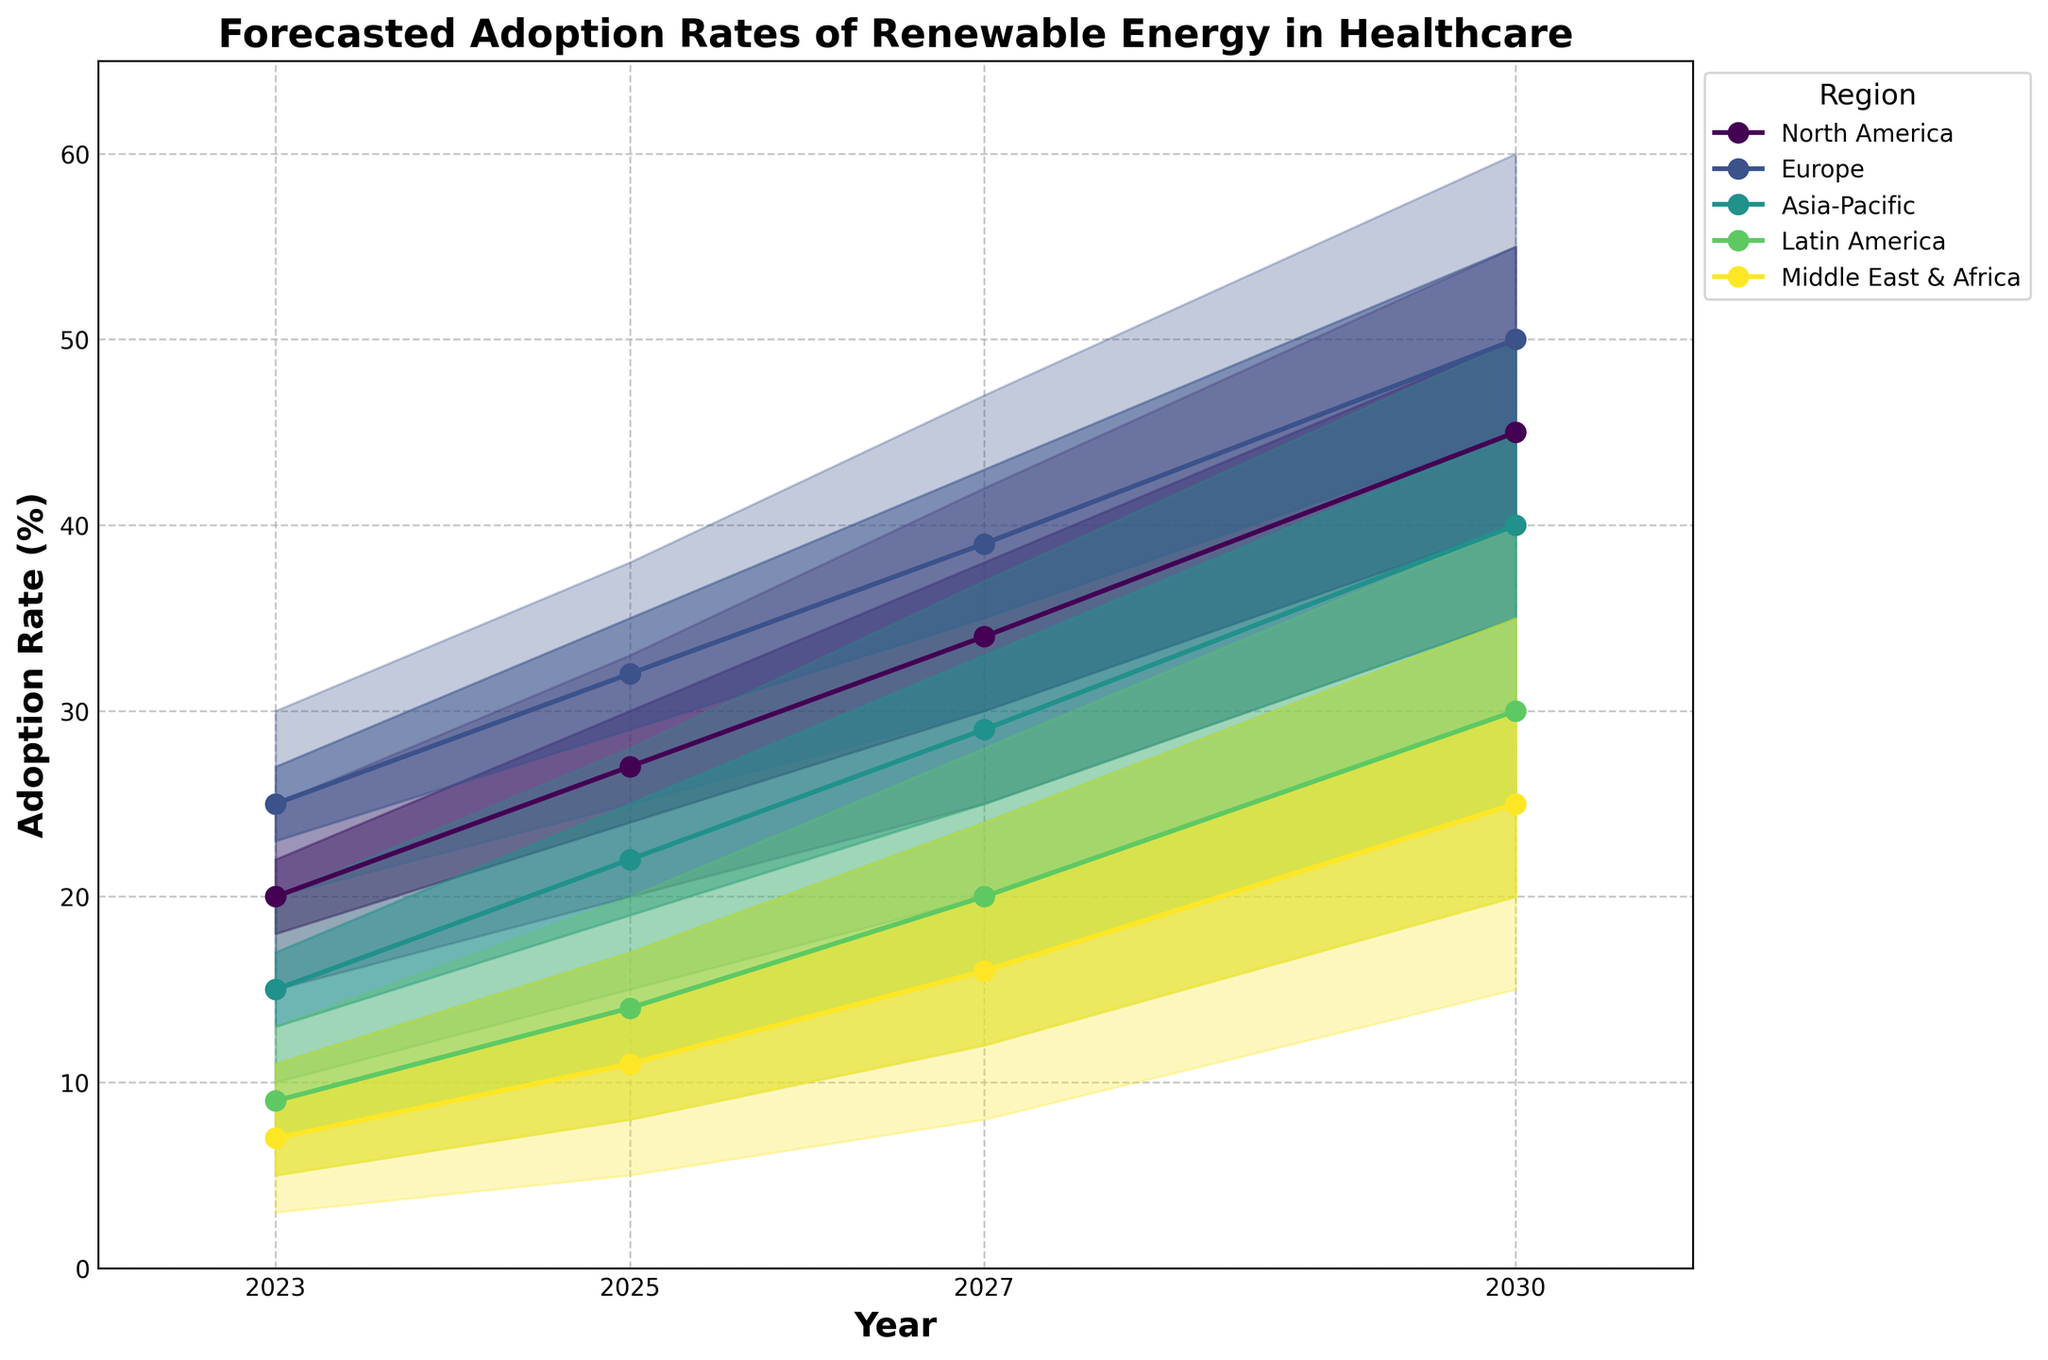What's the title of the chart? The title is usually displayed at the top of a chart. In this case, the title can be found at the top center, indicating the main topic of the chart.
Answer: Forecasted Adoption Rates of Renewable Energy in Healthcare What are the regions covered in the chart? The regions are typically indicated in the legend, which can be found on the figure. They describe the different areas for which data is presented.
Answer: North America, Europe, Asia-Pacific, Latin America, Middle East & Africa By 2027, what is the forecasted middle adoption rate of renewable energy in the Asia-Pacific region? The forecasted middle adoption rate is indicated by the central line in the fan charts for the given year and region. In 2027, for Asia-Pacific, this value is located at the point where the year 2027 intersects with the middle line.
Answer: 29% Which region is expected to have the highest adoption rate of renewable energy by 2030? To determine this, look at the highest forecasted values in 2030 for each region. The topmost line (high) in the fan chart represents this extreme.
Answer: Europe How does the forecasted adoption rate for Latin America in 2025 compare to the Middle East & Africa in 2027? Look at the forecasted middle adoption rates for each region. Latin America's mid-value in 2025 is 14%, and Middle East & Africa's mid-value in 2027 is 16%. Compare these two values.
Answer: The adoption rate in the Middle East & Africa in 2027 is higher What is the difference between the high and low forecasts for Europe in 2025? Find the high and low forecast values for Europe in 2025. The difference is calculated by subtracting the low value from the high value: 38 - 25.
Answer: 13% What trend can be observed for North America's median adoption rate from 2023 to 2030? Observe the median line for North America over the given years to identify the pattern. The median line for North America rises from 2023 (20%) to 2030 (45%).
Answer: Increasing trend For which region is the range (High to Low) of adoption rates largest in 2030? Look at the difference between High and Low values for each region in 2030. The region with the largest difference is obtained by comparing each range. Europe and North America both have the largest range which is 20%.
Answer: Europe and North America In 2025, which region is expected to have a higher adoption rate: Asia-Pacific or Latin America? Compare the middle adoption rates of Asia-Pacific and Latin America in 2025. Asia-Pacific has a mid-value of 22%, while Latin America has a mid-value of 14%.
Answer: Asia-Pacific By 2030, which region has the smallest forecasted range of adoption rates? To find this, compute the difference between the high and low forecasted values for each region in 2030 and identify the smallest difference. Middle East & Africa has the smallest range (35% - 15% = 20%).
Answer: Middle East & Africa 